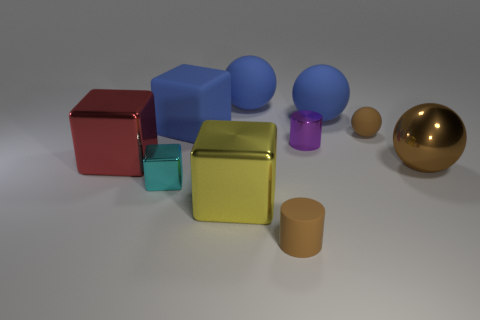Subtract 1 cubes. How many cubes are left? 3 Subtract all balls. How many objects are left? 6 Add 2 purple shiny cylinders. How many purple shiny cylinders are left? 3 Add 5 tiny purple objects. How many tiny purple objects exist? 6 Subtract 0 purple balls. How many objects are left? 10 Subtract all big blue balls. Subtract all matte cylinders. How many objects are left? 7 